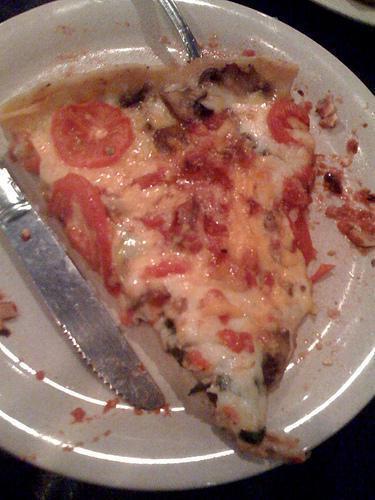How many knives do you see?
Give a very brief answer. 1. How many pieces of silverware do you see?
Give a very brief answer. 2. 